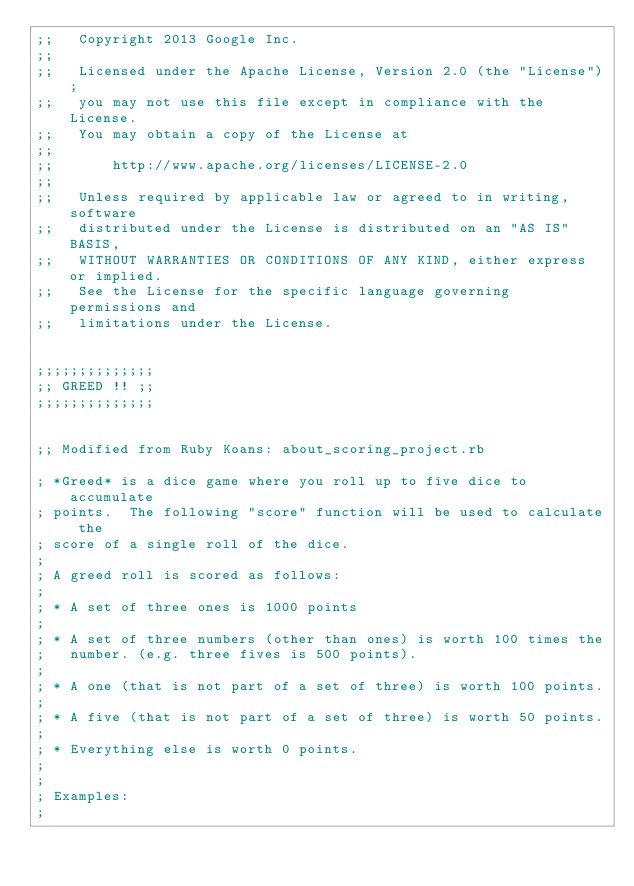Convert code to text. <code><loc_0><loc_0><loc_500><loc_500><_Lisp_>;;   Copyright 2013 Google Inc.
;;
;;   Licensed under the Apache License, Version 2.0 (the "License");
;;   you may not use this file except in compliance with the License.
;;   You may obtain a copy of the License at
;;
;;       http://www.apache.org/licenses/LICENSE-2.0
;;
;;   Unless required by applicable law or agreed to in writing, software
;;   distributed under the License is distributed on an "AS IS" BASIS,
;;   WITHOUT WARRANTIES OR CONDITIONS OF ANY KIND, either express or implied.
;;   See the License for the specific language governing permissions and
;;   limitations under the License.


;;;;;;;;;;;;;;
;; GREED !! ;;
;;;;;;;;;;;;;;


;; Modified from Ruby Koans: about_scoring_project.rb

; *Greed* is a dice game where you roll up to five dice to accumulate
; points.  The following "score" function will be used to calculate the
; score of a single roll of the dice.
;
; A greed roll is scored as follows:
;
; * A set of three ones is 1000 points
;
; * A set of three numbers (other than ones) is worth 100 times the
;   number. (e.g. three fives is 500 points).
;
; * A one (that is not part of a set of three) is worth 100 points.
;
; * A five (that is not part of a set of three) is worth 50 points.
;
; * Everything else is worth 0 points.
;
;
; Examples:
;</code> 